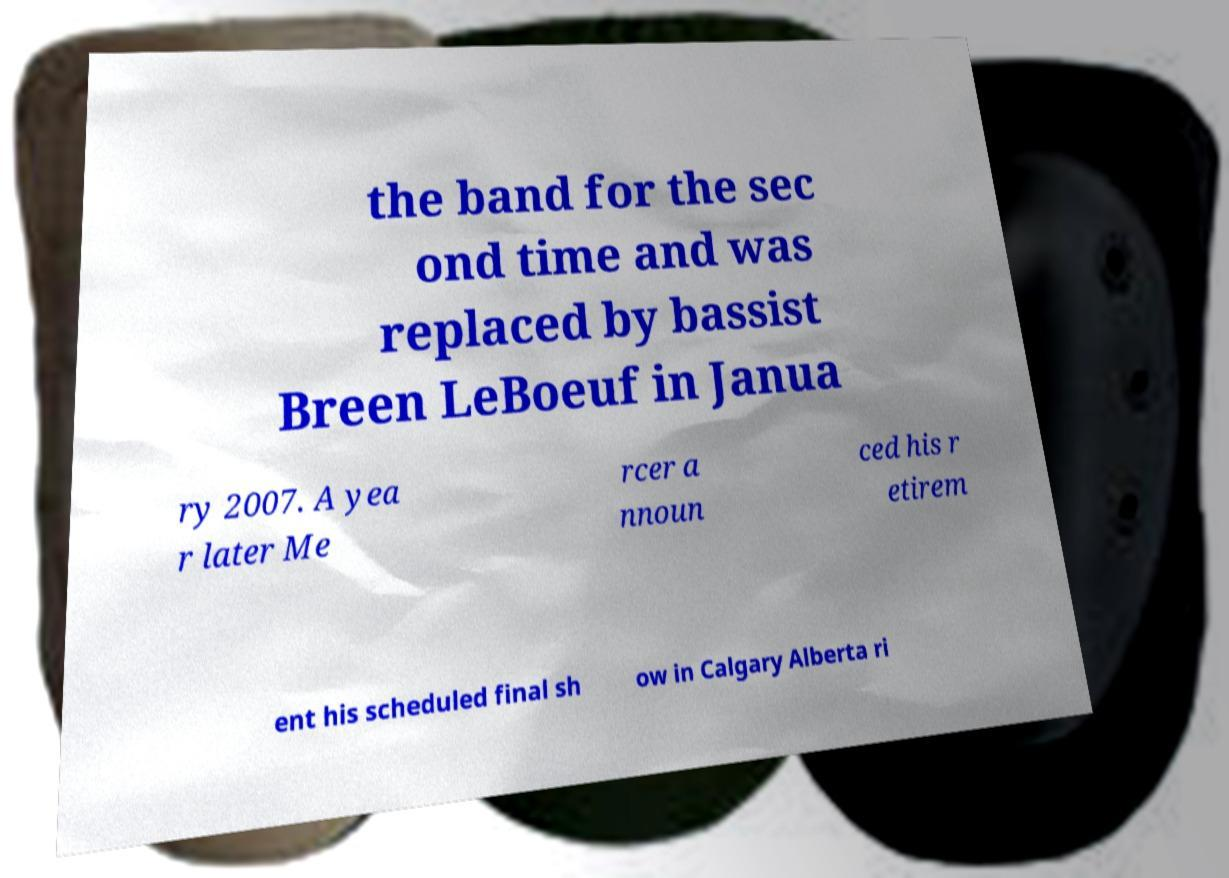Could you extract and type out the text from this image? the band for the sec ond time and was replaced by bassist Breen LeBoeuf in Janua ry 2007. A yea r later Me rcer a nnoun ced his r etirem ent his scheduled final sh ow in Calgary Alberta ri 